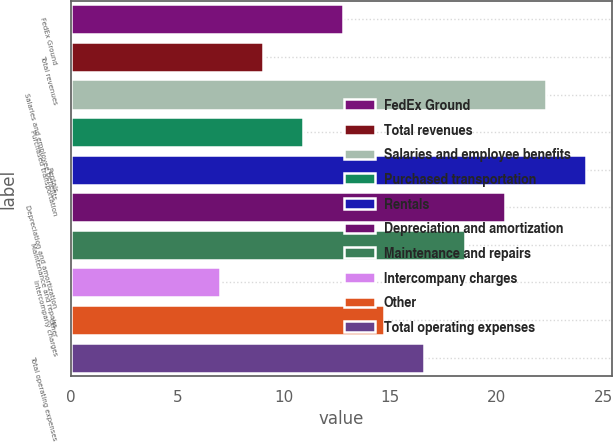Convert chart. <chart><loc_0><loc_0><loc_500><loc_500><bar_chart><fcel>FedEx Ground<fcel>Total revenues<fcel>Salaries and employee benefits<fcel>Purchased transportation<fcel>Rentals<fcel>Depreciation and amortization<fcel>Maintenance and repairs<fcel>Intercompany charges<fcel>Other<fcel>Total operating expenses<nl><fcel>12.8<fcel>9<fcel>22.3<fcel>10.9<fcel>24.2<fcel>20.4<fcel>18.5<fcel>7<fcel>14.7<fcel>16.6<nl></chart> 